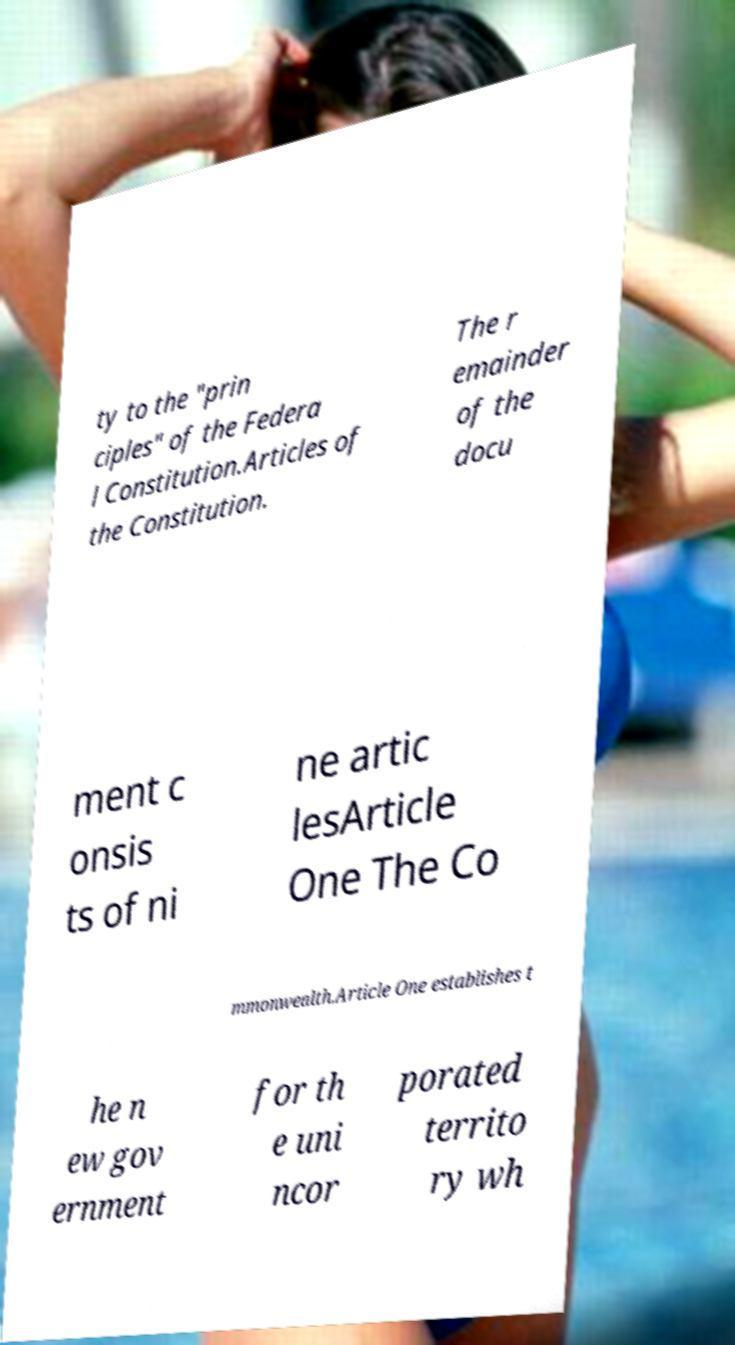Could you assist in decoding the text presented in this image and type it out clearly? ty to the "prin ciples" of the Federa l Constitution.Articles of the Constitution. The r emainder of the docu ment c onsis ts of ni ne artic lesArticle One The Co mmonwealth.Article One establishes t he n ew gov ernment for th e uni ncor porated territo ry wh 